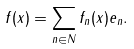<formula> <loc_0><loc_0><loc_500><loc_500>f ( x ) = \sum _ { n \in N } f _ { n } ( x ) e _ { n } .</formula> 